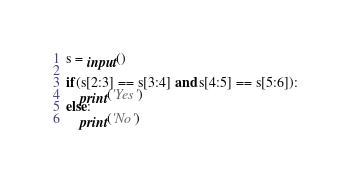Convert code to text. <code><loc_0><loc_0><loc_500><loc_500><_Python_>s = input()

if(s[2:3] == s[3:4] and s[4:5] == s[5:6]):
    print('Yes')
else:
    print('No')</code> 